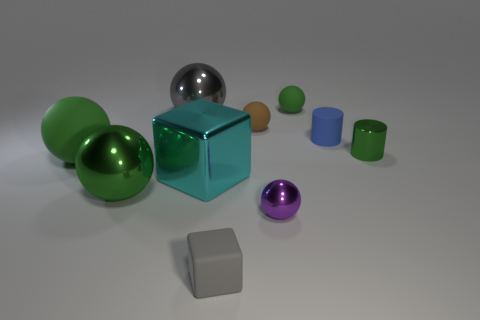There is a tiny metallic thing that is to the right of the tiny green matte sphere; is it the same shape as the tiny blue object behind the green metal ball?
Give a very brief answer. Yes. What is the small blue cylinder made of?
Your answer should be compact. Rubber. There is a sphere on the right side of the small purple thing; what material is it?
Provide a short and direct response. Rubber. Are there any other things that have the same color as the big rubber ball?
Give a very brief answer. Yes. There is a purple ball that is the same material as the small green cylinder; what size is it?
Ensure brevity in your answer.  Small. What number of large things are either gray metal cubes or spheres?
Make the answer very short. 3. What is the size of the green matte object in front of the small matte ball that is in front of the green rubber ball right of the large matte sphere?
Offer a terse response. Large. What number of brown matte objects have the same size as the rubber cylinder?
Your response must be concise. 1. How many things are cyan matte spheres or green rubber things on the left side of the tiny cube?
Provide a succinct answer. 1. What is the shape of the large gray metal thing?
Offer a terse response. Sphere. 